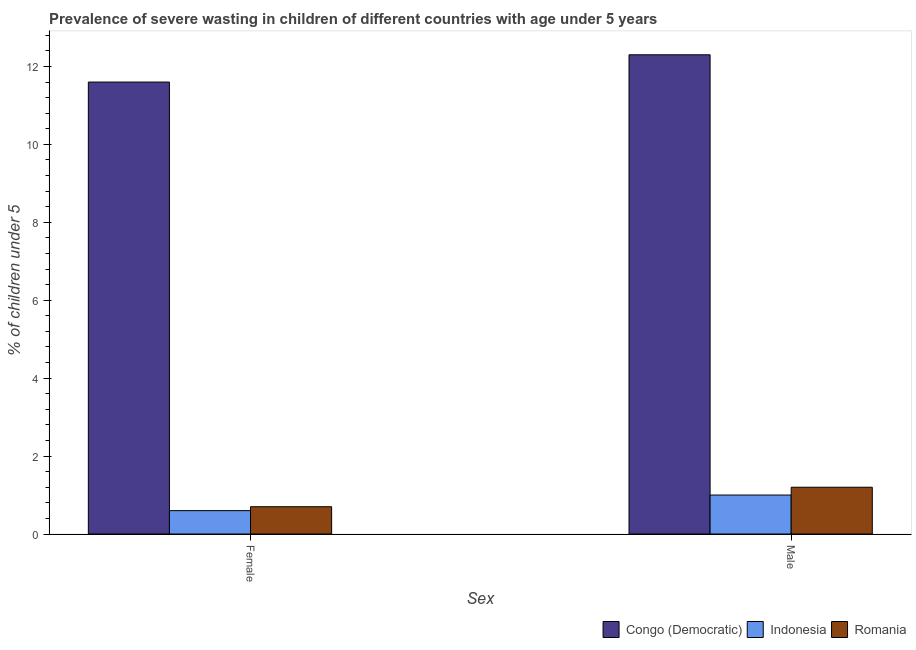How many different coloured bars are there?
Make the answer very short. 3. Are the number of bars on each tick of the X-axis equal?
Offer a terse response. Yes. How many bars are there on the 1st tick from the left?
Your answer should be very brief. 3. How many bars are there on the 1st tick from the right?
Offer a terse response. 3. What is the percentage of undernourished female children in Congo (Democratic)?
Your answer should be very brief. 11.6. Across all countries, what is the maximum percentage of undernourished female children?
Provide a short and direct response. 11.6. Across all countries, what is the minimum percentage of undernourished female children?
Your answer should be compact. 0.6. In which country was the percentage of undernourished male children maximum?
Your answer should be compact. Congo (Democratic). What is the total percentage of undernourished male children in the graph?
Provide a short and direct response. 14.5. What is the difference between the percentage of undernourished female children in Congo (Democratic) and that in Indonesia?
Make the answer very short. 11. What is the difference between the percentage of undernourished male children in Indonesia and the percentage of undernourished female children in Romania?
Your answer should be compact. 0.3. What is the average percentage of undernourished male children per country?
Ensure brevity in your answer.  4.83. What is the difference between the percentage of undernourished female children and percentage of undernourished male children in Romania?
Provide a short and direct response. -0.5. In how many countries, is the percentage of undernourished male children greater than 8 %?
Offer a very short reply. 1. What is the ratio of the percentage of undernourished female children in Indonesia to that in Romania?
Your answer should be very brief. 0.86. What does the 1st bar from the right in Female represents?
Provide a short and direct response. Romania. How many bars are there?
Your response must be concise. 6. How many countries are there in the graph?
Your answer should be compact. 3. Are the values on the major ticks of Y-axis written in scientific E-notation?
Your answer should be very brief. No. Does the graph contain any zero values?
Ensure brevity in your answer.  No. Where does the legend appear in the graph?
Give a very brief answer. Bottom right. What is the title of the graph?
Your answer should be compact. Prevalence of severe wasting in children of different countries with age under 5 years. Does "Costa Rica" appear as one of the legend labels in the graph?
Give a very brief answer. No. What is the label or title of the X-axis?
Provide a short and direct response. Sex. What is the label or title of the Y-axis?
Your answer should be very brief.  % of children under 5. What is the  % of children under 5 in Congo (Democratic) in Female?
Offer a terse response. 11.6. What is the  % of children under 5 of Indonesia in Female?
Give a very brief answer. 0.6. What is the  % of children under 5 of Romania in Female?
Make the answer very short. 0.7. What is the  % of children under 5 in Congo (Democratic) in Male?
Offer a terse response. 12.3. What is the  % of children under 5 of Indonesia in Male?
Your answer should be compact. 1. What is the  % of children under 5 of Romania in Male?
Offer a terse response. 1.2. Across all Sex, what is the maximum  % of children under 5 of Congo (Democratic)?
Your response must be concise. 12.3. Across all Sex, what is the maximum  % of children under 5 of Romania?
Give a very brief answer. 1.2. Across all Sex, what is the minimum  % of children under 5 of Congo (Democratic)?
Your answer should be very brief. 11.6. Across all Sex, what is the minimum  % of children under 5 of Indonesia?
Your answer should be compact. 0.6. Across all Sex, what is the minimum  % of children under 5 in Romania?
Ensure brevity in your answer.  0.7. What is the total  % of children under 5 of Congo (Democratic) in the graph?
Provide a succinct answer. 23.9. What is the total  % of children under 5 in Romania in the graph?
Your answer should be compact. 1.9. What is the difference between the  % of children under 5 in Congo (Democratic) in Female and that in Male?
Keep it short and to the point. -0.7. What is the difference between the  % of children under 5 in Indonesia in Female and that in Male?
Provide a short and direct response. -0.4. What is the difference between the  % of children under 5 in Congo (Democratic) in Female and the  % of children under 5 in Indonesia in Male?
Your answer should be very brief. 10.6. What is the difference between the  % of children under 5 of Indonesia in Female and the  % of children under 5 of Romania in Male?
Provide a short and direct response. -0.6. What is the average  % of children under 5 in Congo (Democratic) per Sex?
Give a very brief answer. 11.95. What is the average  % of children under 5 of Indonesia per Sex?
Make the answer very short. 0.8. What is the difference between the  % of children under 5 in Congo (Democratic) and  % of children under 5 in Indonesia in Female?
Offer a terse response. 11. What is the difference between the  % of children under 5 of Indonesia and  % of children under 5 of Romania in Female?
Your response must be concise. -0.1. What is the difference between the  % of children under 5 of Congo (Democratic) and  % of children under 5 of Romania in Male?
Ensure brevity in your answer.  11.1. What is the ratio of the  % of children under 5 of Congo (Democratic) in Female to that in Male?
Offer a terse response. 0.94. What is the ratio of the  % of children under 5 in Romania in Female to that in Male?
Provide a succinct answer. 0.58. What is the difference between the highest and the second highest  % of children under 5 in Congo (Democratic)?
Make the answer very short. 0.7. What is the difference between the highest and the second highest  % of children under 5 of Romania?
Ensure brevity in your answer.  0.5. What is the difference between the highest and the lowest  % of children under 5 of Congo (Democratic)?
Offer a very short reply. 0.7. What is the difference between the highest and the lowest  % of children under 5 of Indonesia?
Offer a terse response. 0.4. What is the difference between the highest and the lowest  % of children under 5 in Romania?
Provide a succinct answer. 0.5. 